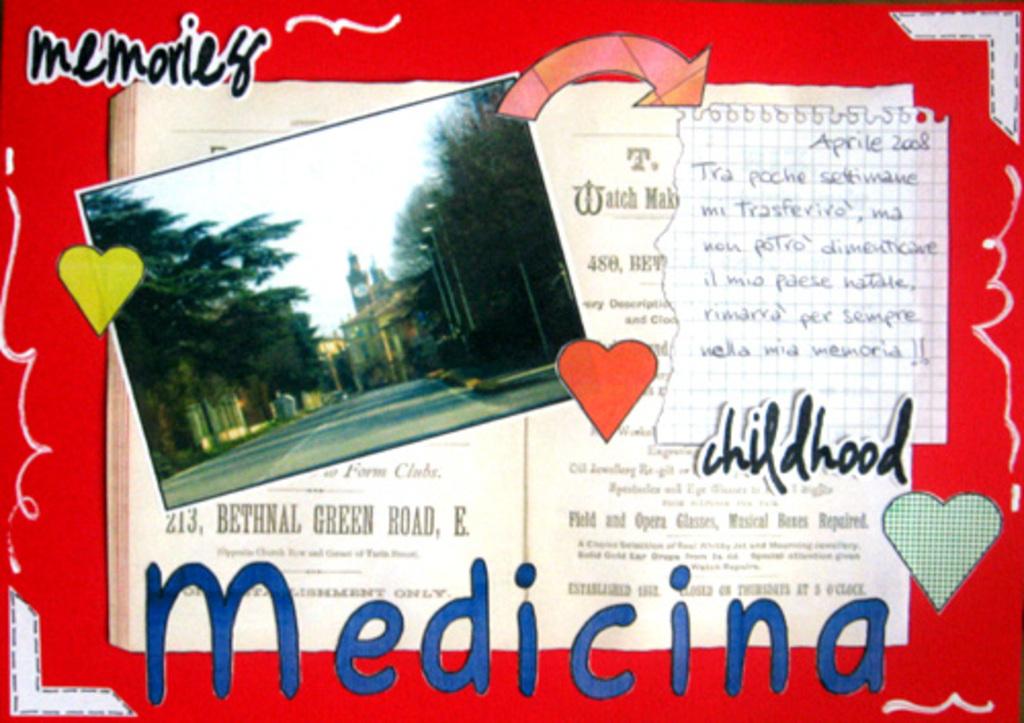What childhood memories is the book keeping a record of?
Offer a very short reply. Unanswerable. What does the ad say?
Offer a terse response. Medicina. 